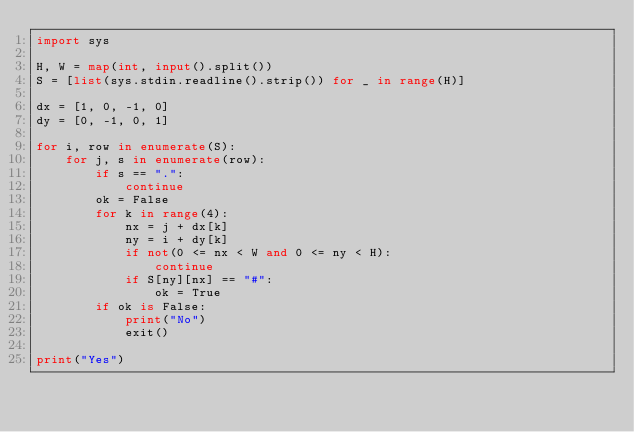Convert code to text. <code><loc_0><loc_0><loc_500><loc_500><_Python_>import sys

H, W = map(int, input().split())
S = [list(sys.stdin.readline().strip()) for _ in range(H)]

dx = [1, 0, -1, 0]
dy = [0, -1, 0, 1]

for i, row in enumerate(S):
    for j, s in enumerate(row):
        if s == ".":
            continue
        ok = False
        for k in range(4):
            nx = j + dx[k]
            ny = i + dy[k]
            if not(0 <= nx < W and 0 <= ny < H):
                continue
            if S[ny][nx] == "#":
                ok = True
        if ok is False:
            print("No")
            exit()

print("Yes")
</code> 